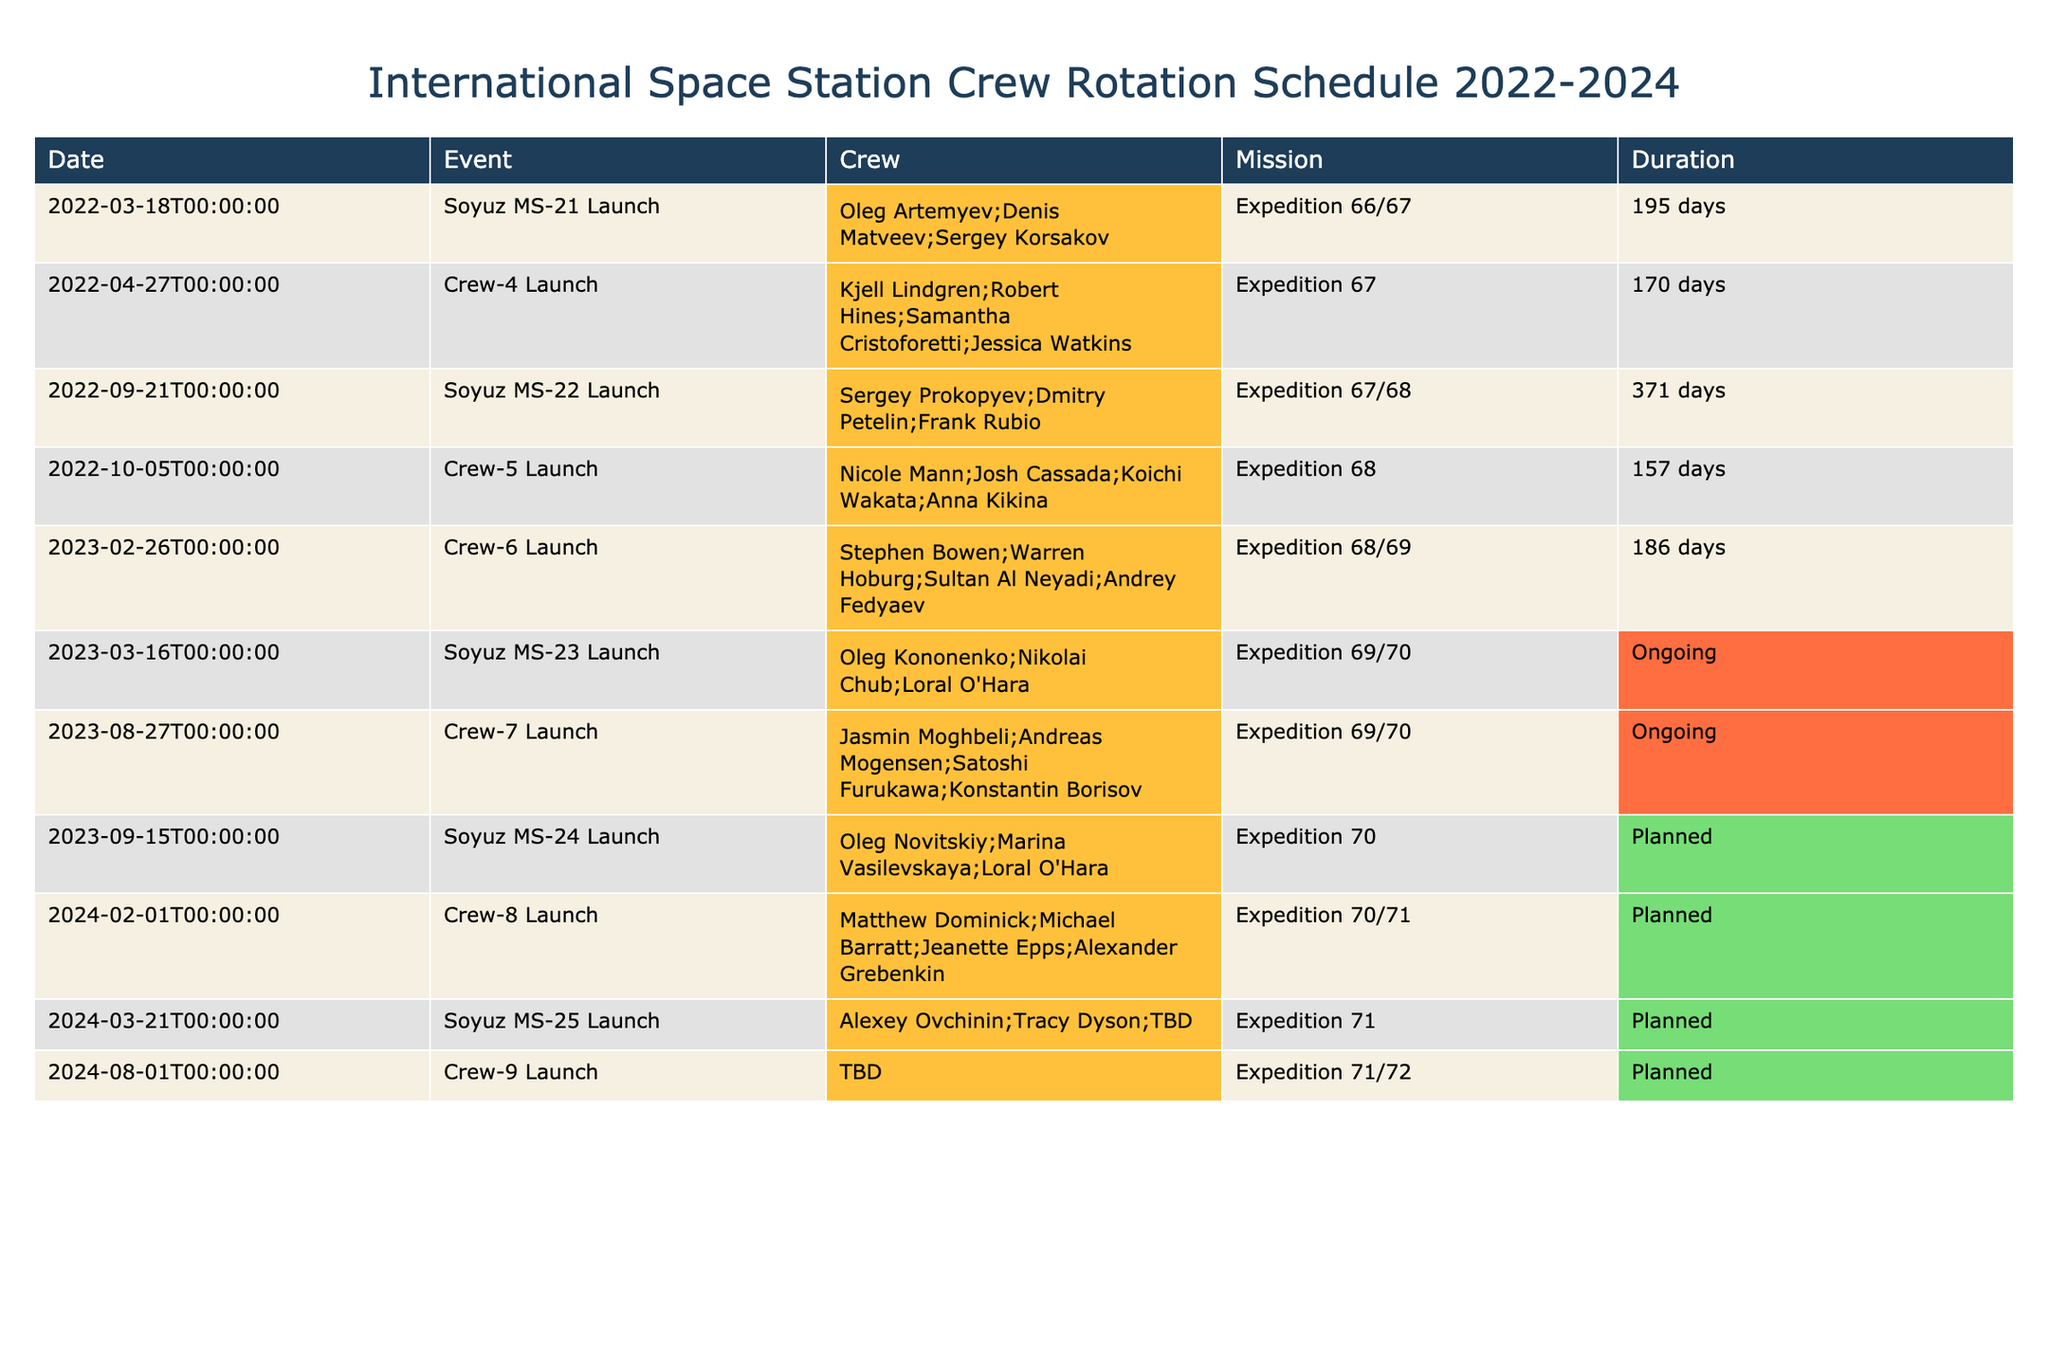What is the longest duration mission listed in the table? The longest duration mission can be determined by reviewing the "Duration" column and identifying the maximum value. In this case, the mission "Soyuz MS-22 Launch" has a duration of "371 days," which is greater than all other listed durations.
Answer: 371 days How many launches are planned after March 2024? To find this, we check the "Date" column for launches occurring after March 2024. The entries show that "Crew-9 Launch" on "2024-08-01" is the only planned launch after March 2024.
Answer: 1 Which crew members are on the Soyuz MS-23 mission? Referring to the "Crew" column, we find that the "Soyuz MS-23 Launch" lists the crew members as "Oleg Kononenko; Nikolai Chub; Loral O'Hara." This information is taken directly from the table under the corresponding event.
Answer: Oleg Kononenko; Nikolai Chub; Loral O'Hara How many crew members participated in the Crew-6 Launch? The "Crew-6 Launch" entry has a crew listed as "Stephen Bowen; Warren Hoburg; Sultan Al Neyadi; Andrey Fedyaev." Counting these names gives us a total of four crew members.
Answer: 4 Is there any mission that is currently ongoing? By examining the "Duration" column, we see that both the "Soyuz MS-23 Launch" and "Crew-7 Launch" are labeled as "Ongoing." This confirms that there are active missions currently.
Answer: Yes How many total crew members are expected for the planned missions? Analyzing the "Crew" column for each scheduled "Planned" mission reveals the following: "Crew-8 Launch" has 4 members and "Soyuz MS-25 Launch" has 3 (TBD noted as unknown), and "Crew-9 Launch" has a total of 4 members (TBD noted as unknown). Adding them results in 4 (Crew-8) + 3 (Soyuz MS-25) + 4 (Crew-9) = 11 expected crew members. This is a total from all defined planned missions, excluding TBD names as uncertainty for now.
Answer: 11 What is the next mission scheduled after Crew-7? Referring to the "Date" column, we see "Soyuz MS-24 Launch" scheduled on "2023-09-15." Since it follows "Crew-7 Launch" on "2023-08-27," this is the immediate next mission after Crew-7.
Answer: Soyuz MS-24 Launch If a mission takes 195 days, how many missions have longer durations than that? The "Duration" values of missions can be compared to 195 days. The missions: "Soyuz MS-22 Launch" (371 days), "Soyuz MS-23 Launch" (Ongoing), and "Crew-6 Launch" (186 days) exceed 195 days. In total, there are 3 missions that have longer durations than 195 days.
Answer: 3 Which expedition has the most launches associated with it? By cross-referencing the "Expedition" column with the "Event" entries, we find Expedition 67 has two launches (Crew-4 and Soyuz MS-22), Expedition 68 also has two (Crew-5 and Crew-6), and Expeditions 69 and 71 each have one planned one, thus noting that Expedition 67 and 68 each have the greatest association at this moment.
Answer: Expeditions 67 and 68 